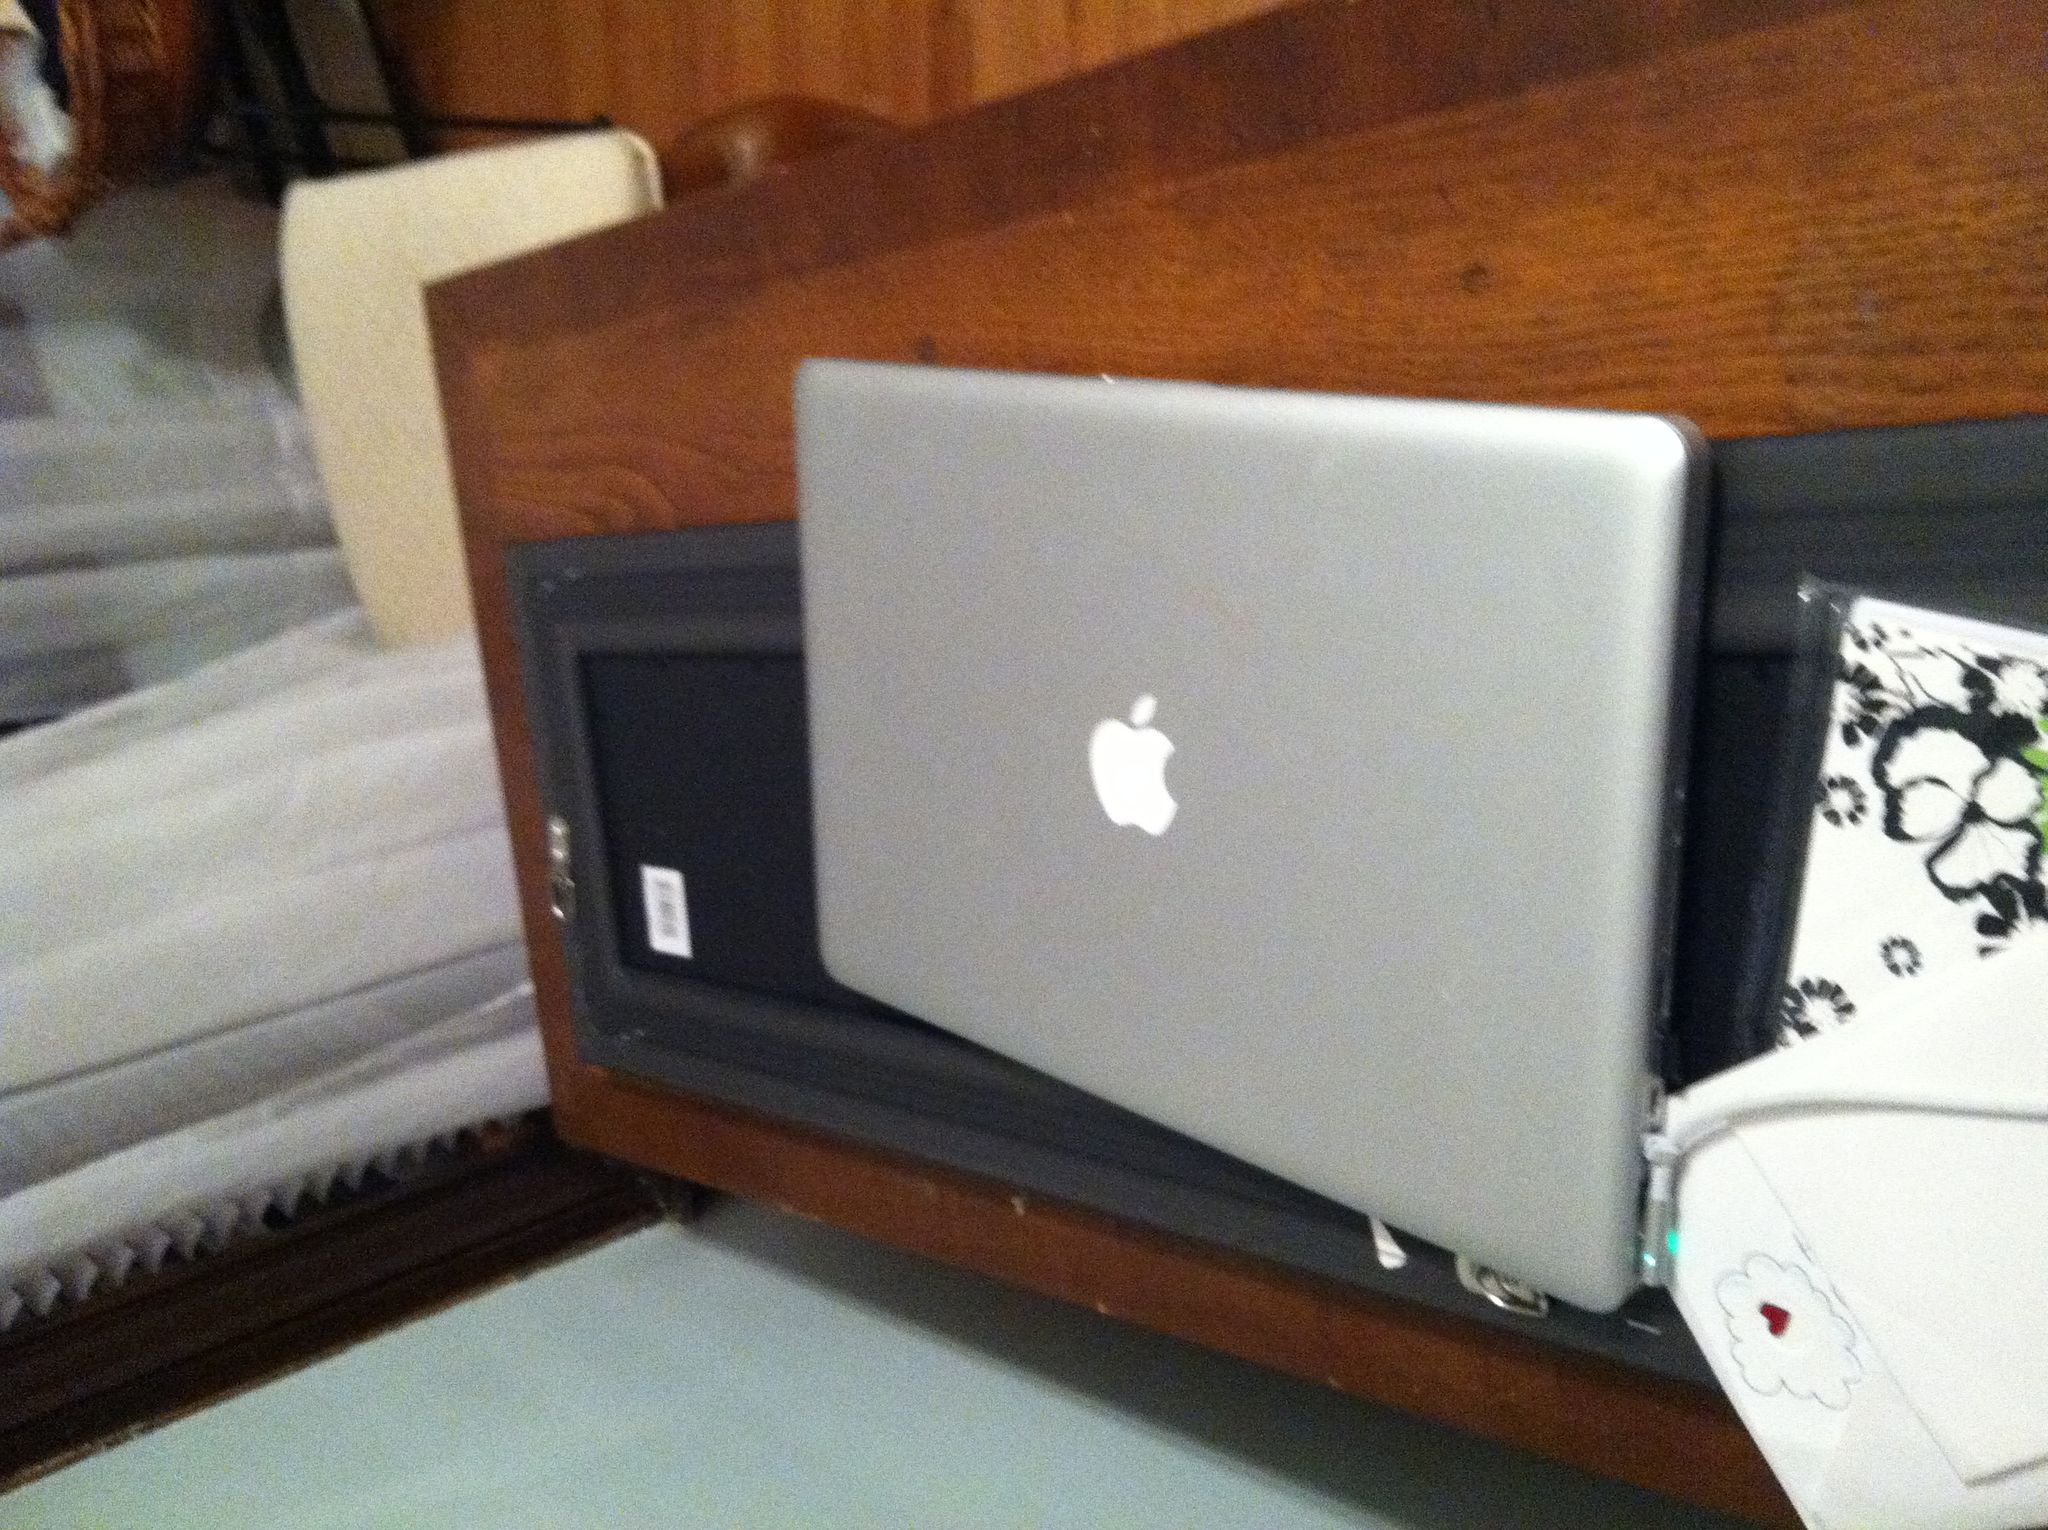Can you tell more about the historical significance of the iBook? The iBook, launched by Apple in the late 1990s, was significant as it was one of the first laptops aimed at the consumer market instead of business professionals. It featured a rugged design and wireless networking capabilities, which helped popularize Wi-Fi technology. 